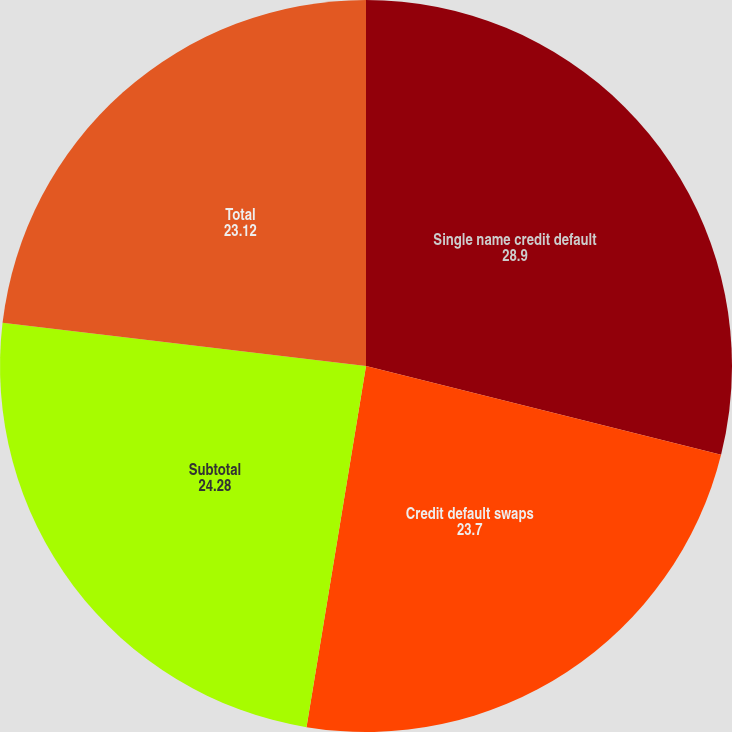Convert chart to OTSL. <chart><loc_0><loc_0><loc_500><loc_500><pie_chart><fcel>Single name credit default<fcel>Credit default swaps<fcel>Subtotal<fcel>Total<nl><fcel>28.9%<fcel>23.7%<fcel>24.28%<fcel>23.12%<nl></chart> 